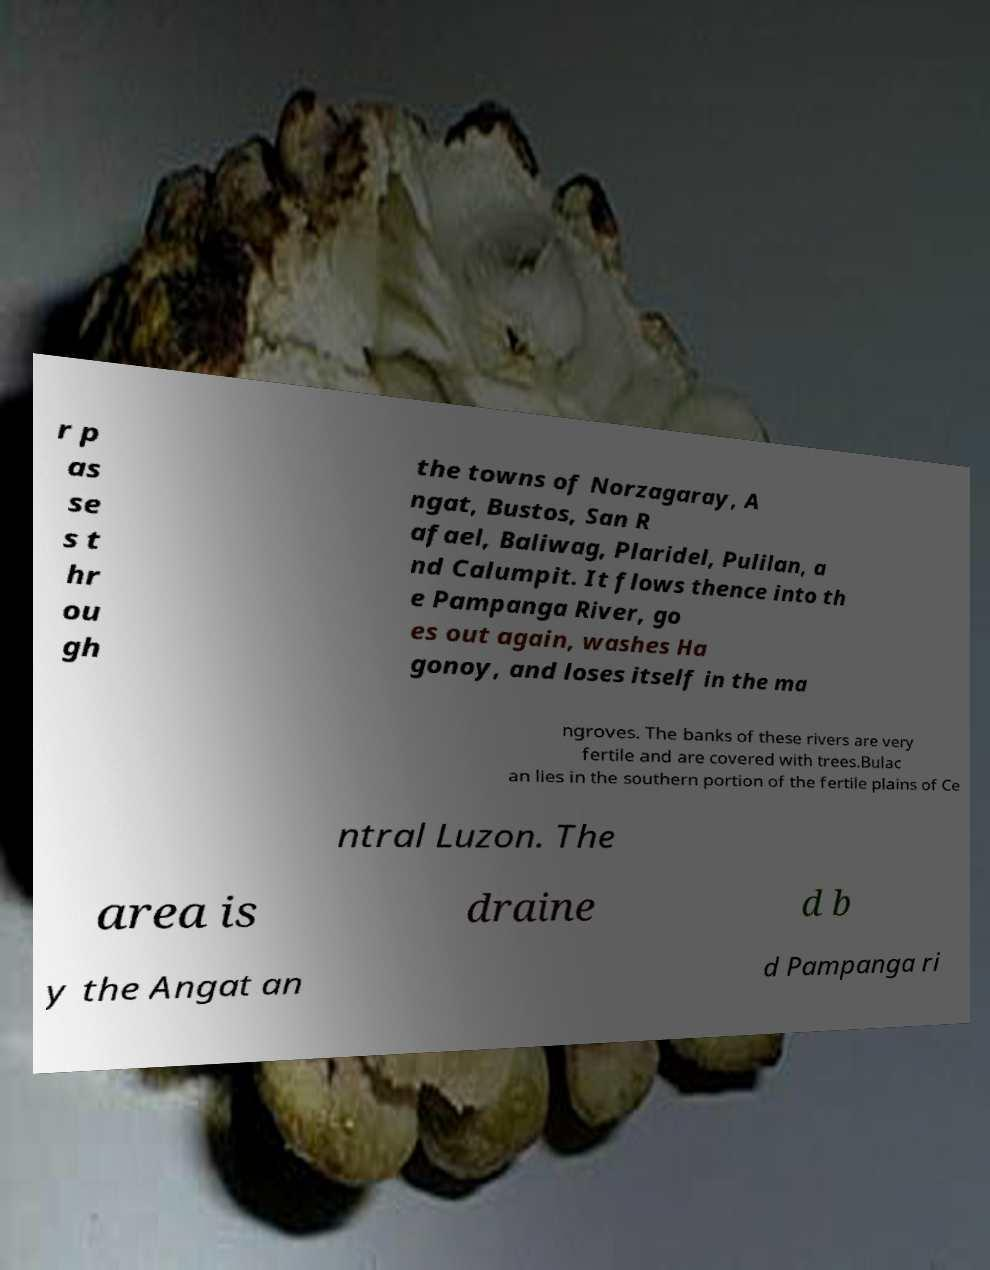Please identify and transcribe the text found in this image. r p as se s t hr ou gh the towns of Norzagaray, A ngat, Bustos, San R afael, Baliwag, Plaridel, Pulilan, a nd Calumpit. It flows thence into th e Pampanga River, go es out again, washes Ha gonoy, and loses itself in the ma ngroves. The banks of these rivers are very fertile and are covered with trees.Bulac an lies in the southern portion of the fertile plains of Ce ntral Luzon. The area is draine d b y the Angat an d Pampanga ri 